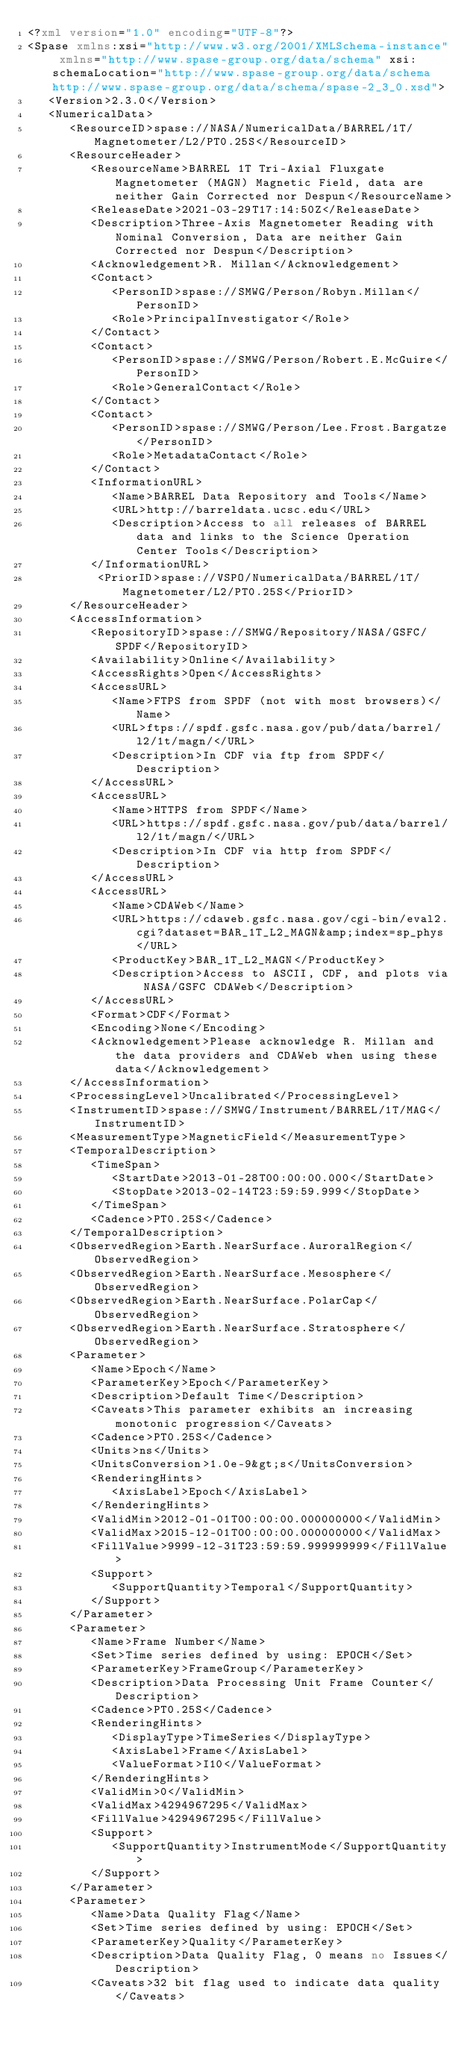<code> <loc_0><loc_0><loc_500><loc_500><_XML_><?xml version="1.0" encoding="UTF-8"?>
<Spase xmlns:xsi="http://www.w3.org/2001/XMLSchema-instance" xmlns="http://www.spase-group.org/data/schema" xsi:schemaLocation="http://www.spase-group.org/data/schema http://www.spase-group.org/data/schema/spase-2_3_0.xsd">
   <Version>2.3.0</Version>
   <NumericalData>
      <ResourceID>spase://NASA/NumericalData/BARREL/1T/Magnetometer/L2/PT0.25S</ResourceID>
      <ResourceHeader>
         <ResourceName>BARREL 1T Tri-Axial Fluxgate Magnetometer (MAGN) Magnetic Field, data are neither Gain Corrected nor Despun</ResourceName>
         <ReleaseDate>2021-03-29T17:14:50Z</ReleaseDate>
         <Description>Three-Axis Magnetometer Reading with Nominal Conversion, Data are neither Gain Corrected nor Despun</Description>
         <Acknowledgement>R. Millan</Acknowledgement>
         <Contact>
            <PersonID>spase://SMWG/Person/Robyn.Millan</PersonID>
            <Role>PrincipalInvestigator</Role>
         </Contact>
         <Contact>
            <PersonID>spase://SMWG/Person/Robert.E.McGuire</PersonID>
            <Role>GeneralContact</Role>
         </Contact>
         <Contact>
            <PersonID>spase://SMWG/Person/Lee.Frost.Bargatze</PersonID>
            <Role>MetadataContact</Role>
         </Contact>
         <InformationURL>
            <Name>BARREL Data Repository and Tools</Name>
            <URL>http://barreldata.ucsc.edu</URL>
            <Description>Access to all releases of BARREL data and links to the Science Operation Center Tools</Description>
         </InformationURL>
          <PriorID>spase://VSPO/NumericalData/BARREL/1T/Magnetometer/L2/PT0.25S</PriorID>
      </ResourceHeader>
      <AccessInformation>
         <RepositoryID>spase://SMWG/Repository/NASA/GSFC/SPDF</RepositoryID>
         <Availability>Online</Availability>
         <AccessRights>Open</AccessRights>
         <AccessURL>
            <Name>FTPS from SPDF (not with most browsers)</Name>
            <URL>ftps://spdf.gsfc.nasa.gov/pub/data/barrel/l2/1t/magn/</URL>
            <Description>In CDF via ftp from SPDF</Description>
         </AccessURL>
         <AccessURL>
            <Name>HTTPS from SPDF</Name>
            <URL>https://spdf.gsfc.nasa.gov/pub/data/barrel/l2/1t/magn/</URL>
            <Description>In CDF via http from SPDF</Description>
         </AccessURL>
         <AccessURL>
            <Name>CDAWeb</Name>
            <URL>https://cdaweb.gsfc.nasa.gov/cgi-bin/eval2.cgi?dataset=BAR_1T_L2_MAGN&amp;index=sp_phys</URL>
            <ProductKey>BAR_1T_L2_MAGN</ProductKey>
            <Description>Access to ASCII, CDF, and plots via NASA/GSFC CDAWeb</Description>
         </AccessURL>
         <Format>CDF</Format>
         <Encoding>None</Encoding>
         <Acknowledgement>Please acknowledge R. Millan and the data providers and CDAWeb when using these data</Acknowledgement>
      </AccessInformation>
      <ProcessingLevel>Uncalibrated</ProcessingLevel>
      <InstrumentID>spase://SMWG/Instrument/BARREL/1T/MAG</InstrumentID>
      <MeasurementType>MagneticField</MeasurementType>
      <TemporalDescription>
         <TimeSpan>
            <StartDate>2013-01-28T00:00:00.000</StartDate>
            <StopDate>2013-02-14T23:59:59.999</StopDate>
         </TimeSpan>
         <Cadence>PT0.25S</Cadence>
      </TemporalDescription>
      <ObservedRegion>Earth.NearSurface.AuroralRegion</ObservedRegion>
      <ObservedRegion>Earth.NearSurface.Mesosphere</ObservedRegion>
      <ObservedRegion>Earth.NearSurface.PolarCap</ObservedRegion>
      <ObservedRegion>Earth.NearSurface.Stratosphere</ObservedRegion>
      <Parameter>
         <Name>Epoch</Name>
         <ParameterKey>Epoch</ParameterKey>
         <Description>Default Time</Description>
         <Caveats>This parameter exhibits an increasing monotonic progression</Caveats>
         <Cadence>PT0.25S</Cadence>
         <Units>ns</Units>
         <UnitsConversion>1.0e-9&gt;s</UnitsConversion>
         <RenderingHints>
            <AxisLabel>Epoch</AxisLabel>
         </RenderingHints>
         <ValidMin>2012-01-01T00:00:00.000000000</ValidMin>
         <ValidMax>2015-12-01T00:00:00.000000000</ValidMax>
         <FillValue>9999-12-31T23:59:59.999999999</FillValue>
         <Support>
            <SupportQuantity>Temporal</SupportQuantity>
         </Support>
      </Parameter>
      <Parameter>
         <Name>Frame Number</Name>
         <Set>Time series defined by using: EPOCH</Set>
         <ParameterKey>FrameGroup</ParameterKey>
         <Description>Data Processing Unit Frame Counter</Description>
         <Cadence>PT0.25S</Cadence>
         <RenderingHints>
            <DisplayType>TimeSeries</DisplayType>
            <AxisLabel>Frame</AxisLabel>
            <ValueFormat>I10</ValueFormat>
         </RenderingHints>
         <ValidMin>0</ValidMin>
         <ValidMax>4294967295</ValidMax>
         <FillValue>4294967295</FillValue>
         <Support>
            <SupportQuantity>InstrumentMode</SupportQuantity>
         </Support>
      </Parameter>
      <Parameter>
         <Name>Data Quality Flag</Name>
         <Set>Time series defined by using: EPOCH</Set>
         <ParameterKey>Quality</ParameterKey>
         <Description>Data Quality Flag, 0 means no Issues</Description>
         <Caveats>32 bit flag used to indicate data quality</Caveats></code> 